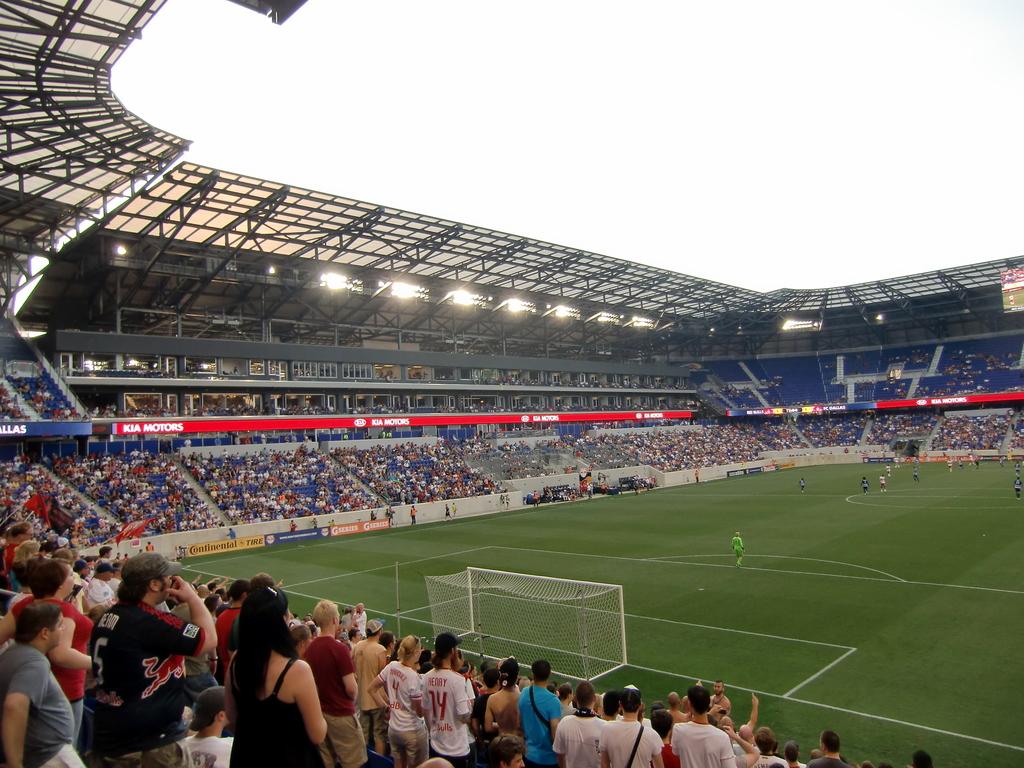What motor company name is being displayed?
Offer a very short reply. Kia motors. 